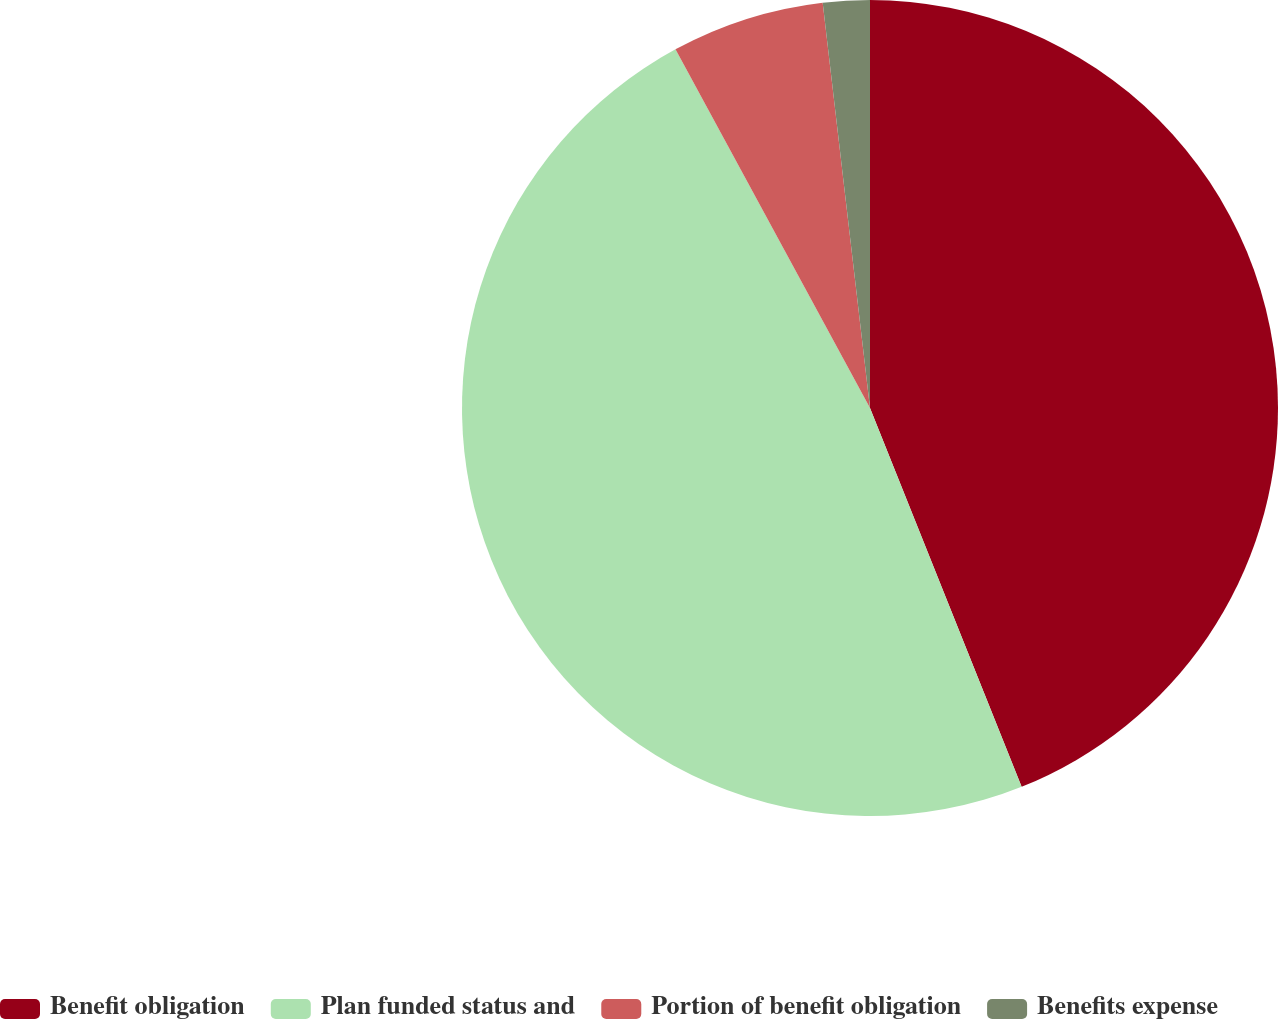Convert chart. <chart><loc_0><loc_0><loc_500><loc_500><pie_chart><fcel>Benefit obligation<fcel>Plan funded status and<fcel>Portion of benefit obligation<fcel>Benefits expense<nl><fcel>43.94%<fcel>48.15%<fcel>6.06%<fcel>1.85%<nl></chart> 